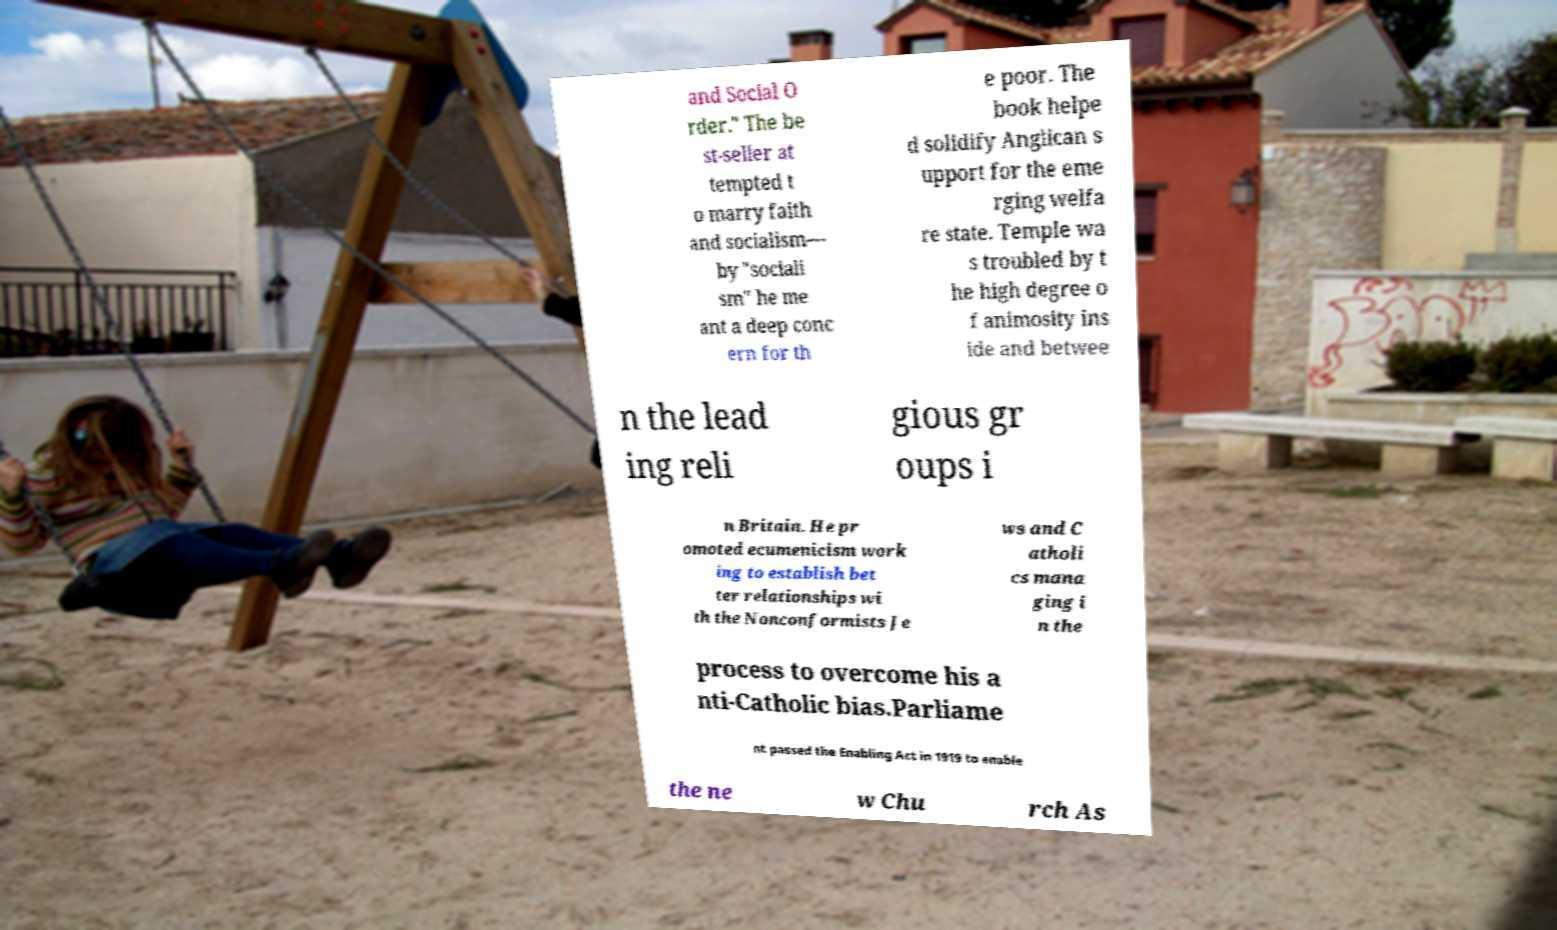What messages or text are displayed in this image? I need them in a readable, typed format. and Social O rder." The be st-seller at tempted t o marry faith and socialism— by "sociali sm" he me ant a deep conc ern for th e poor. The book helpe d solidify Anglican s upport for the eme rging welfa re state. Temple wa s troubled by t he high degree o f animosity ins ide and betwee n the lead ing reli gious gr oups i n Britain. He pr omoted ecumenicism work ing to establish bet ter relationships wi th the Nonconformists Je ws and C atholi cs mana ging i n the process to overcome his a nti-Catholic bias.Parliame nt passed the Enabling Act in 1919 to enable the ne w Chu rch As 